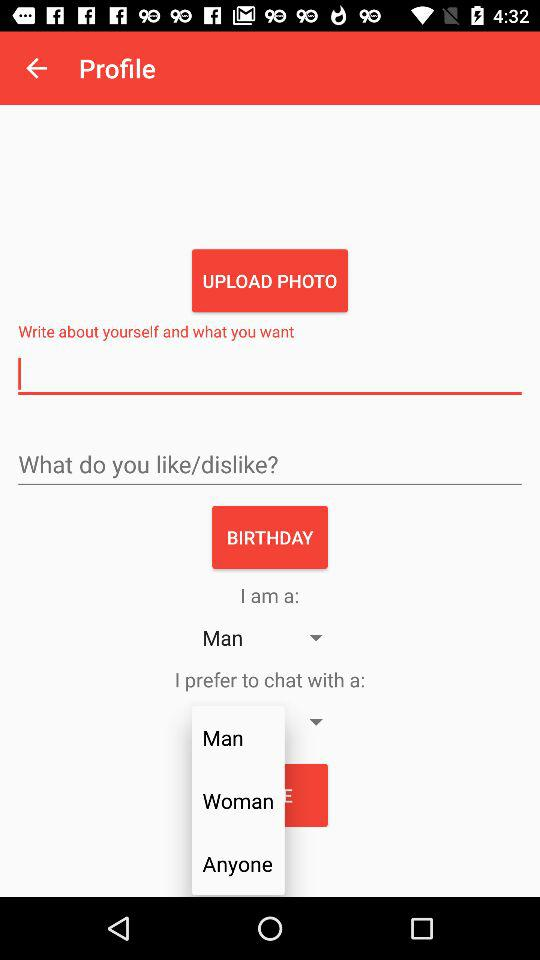What are the options given in "I prefer to chat with a:"? The given options are "Man", "Woman" and "Anyone". 